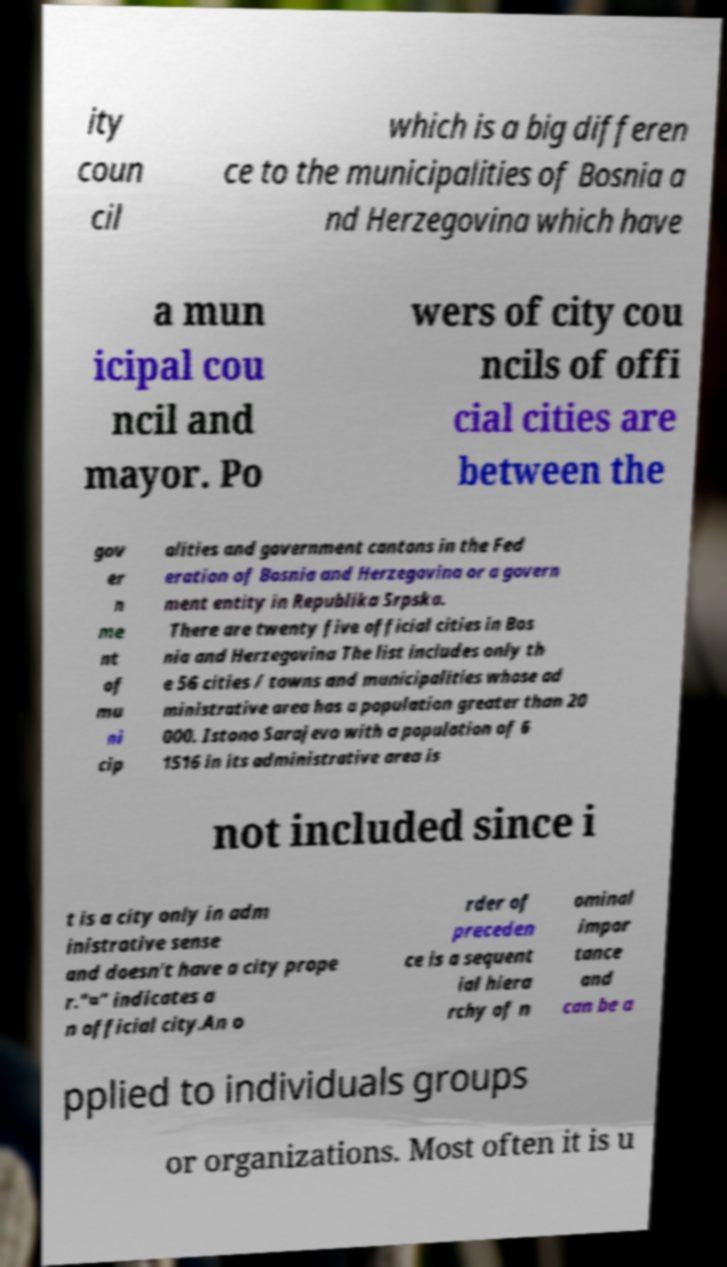What messages or text are displayed in this image? I need them in a readable, typed format. ity coun cil which is a big differen ce to the municipalities of Bosnia a nd Herzegovina which have a mun icipal cou ncil and mayor. Po wers of city cou ncils of offi cial cities are between the gov er n me nt of mu ni cip alities and government cantons in the Fed eration of Bosnia and Herzegovina or a govern ment entity in Republika Srpska. There are twenty five official cities in Bos nia and Herzegovina The list includes only th e 56 cities / towns and municipalities whose ad ministrative area has a population greater than 20 000. Istono Sarajevo with a population of 6 1516 in its administrative area is not included since i t is a city only in adm inistrative sense and doesn't have a city prope r."¤" indicates a n official city.An o rder of preceden ce is a sequent ial hiera rchy of n ominal impor tance and can be a pplied to individuals groups or organizations. Most often it is u 